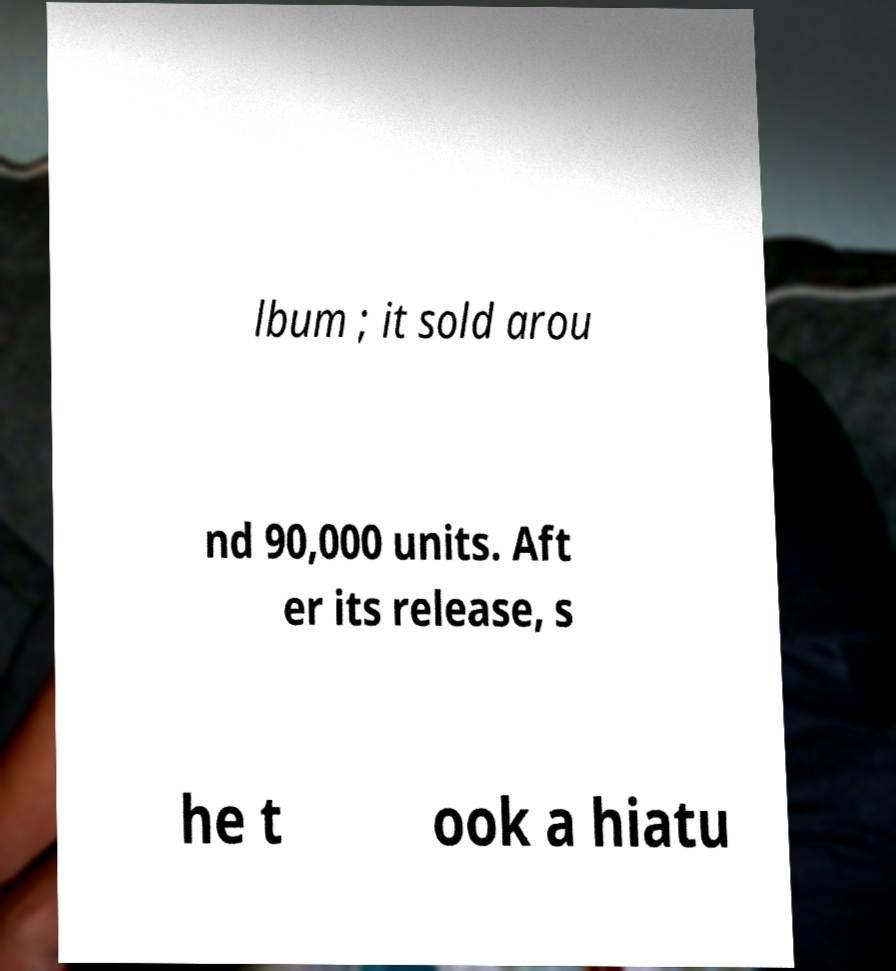Can you accurately transcribe the text from the provided image for me? lbum ; it sold arou nd 90,000 units. Aft er its release, s he t ook a hiatu 